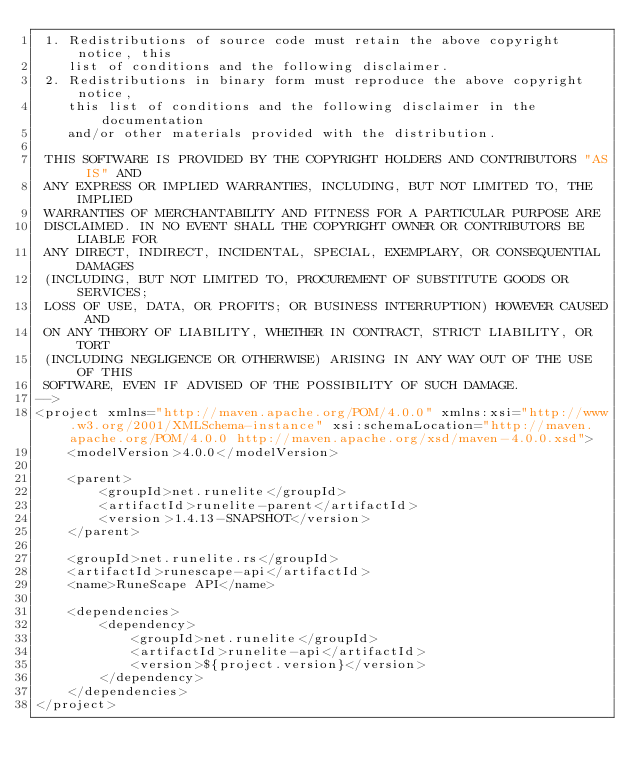Convert code to text. <code><loc_0><loc_0><loc_500><loc_500><_XML_> 1. Redistributions of source code must retain the above copyright notice, this
    list of conditions and the following disclaimer.
 2. Redistributions in binary form must reproduce the above copyright notice,
    this list of conditions and the following disclaimer in the documentation
    and/or other materials provided with the distribution.

 THIS SOFTWARE IS PROVIDED BY THE COPYRIGHT HOLDERS AND CONTRIBUTORS "AS IS" AND
 ANY EXPRESS OR IMPLIED WARRANTIES, INCLUDING, BUT NOT LIMITED TO, THE IMPLIED
 WARRANTIES OF MERCHANTABILITY AND FITNESS FOR A PARTICULAR PURPOSE ARE
 DISCLAIMED. IN NO EVENT SHALL THE COPYRIGHT OWNER OR CONTRIBUTORS BE LIABLE FOR
 ANY DIRECT, INDIRECT, INCIDENTAL, SPECIAL, EXEMPLARY, OR CONSEQUENTIAL DAMAGES
 (INCLUDING, BUT NOT LIMITED TO, PROCUREMENT OF SUBSTITUTE GOODS OR SERVICES;
 LOSS OF USE, DATA, OR PROFITS; OR BUSINESS INTERRUPTION) HOWEVER CAUSED AND
 ON ANY THEORY OF LIABILITY, WHETHER IN CONTRACT, STRICT LIABILITY, OR TORT
 (INCLUDING NEGLIGENCE OR OTHERWISE) ARISING IN ANY WAY OUT OF THE USE OF THIS
 SOFTWARE, EVEN IF ADVISED OF THE POSSIBILITY OF SUCH DAMAGE.
-->
<project xmlns="http://maven.apache.org/POM/4.0.0" xmlns:xsi="http://www.w3.org/2001/XMLSchema-instance" xsi:schemaLocation="http://maven.apache.org/POM/4.0.0 http://maven.apache.org/xsd/maven-4.0.0.xsd">
	<modelVersion>4.0.0</modelVersion>

	<parent>
		<groupId>net.runelite</groupId>
		<artifactId>runelite-parent</artifactId>
		<version>1.4.13-SNAPSHOT</version>
	</parent>

	<groupId>net.runelite.rs</groupId>
	<artifactId>runescape-api</artifactId>
	<name>RuneScape API</name>

	<dependencies>
		<dependency>
			<groupId>net.runelite</groupId>
			<artifactId>runelite-api</artifactId>
			<version>${project.version}</version>
		</dependency>
	</dependencies>
</project>
</code> 